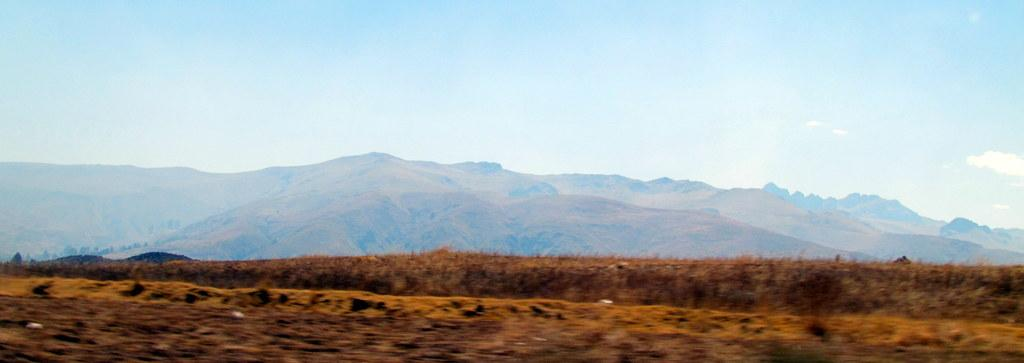What type of landscape is depicted in the image? There is a field in the image. What is the terrain like at the bottom of the image? There is a grassy land at the bottom of the image. What geographical feature can be seen in the middle of the image? There are mountains in the middle of the image. What is visible in the background of the image? The sky is visible in the background of the image. How many shoes can be seen in the image? There are no shoes present in the image. What type of arch can be seen in the image? There is no arch present in the image. 